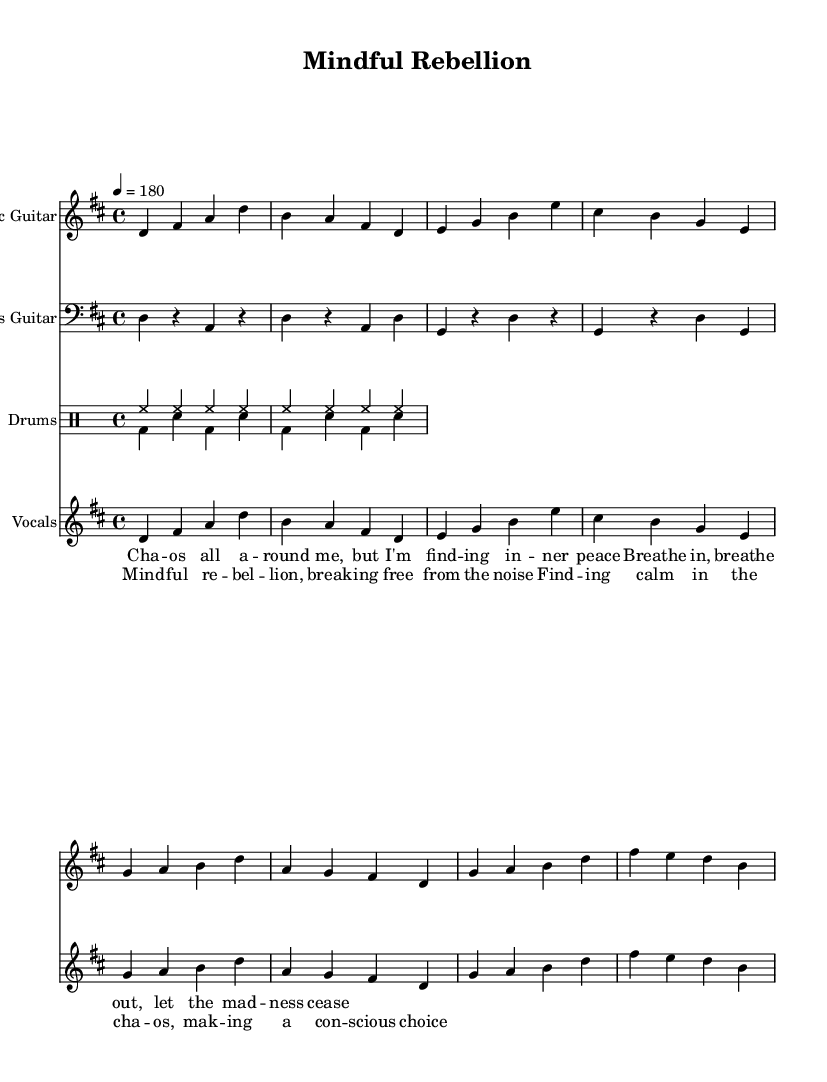What is the key signature of this music? The key signature is D major, which has two sharps: F# and C#.
Answer: D major What is the time signature of this music? The time signature is 4/4, indicating four beats per measure with a quarter note receiving one beat.
Answer: 4/4 What is the tempo marking of this piece? The tempo marking indicates a speed of 180 beats per minute, which means the piece is quite fast and energetic.
Answer: 180 What instruments are included in the score? The score includes electric guitar, bass guitar, drums, and vocals, defined in the separate staves.
Answer: Electric guitar, bass guitar, drums, vocals What is the theme expressed in the lyrics of the chorus? The theme in the lyrics expresses a struggle for inner peace amid chaos, highlighting mindfulness and conscious choice.
Answer: Mindfulness and inner peace How many measures are in the verse section? The verse section contains a total of 8 measures, as counted in the vocal melody line.
Answer: 8 measures What is the overall style of the music based on its structure and lyrics? The overall style is melodic punk rock, evident from the upbeat tempo, chord progressions, and themes of rebellion and mindfulness in the lyrics.
Answer: Melodic punk rock 